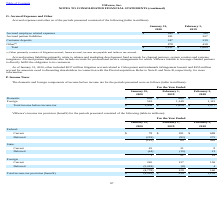From Vmware's financial document, Which years does the table provide information for the domestic and foreign components of income before income tax? The document contains multiple relevant values: 2020, 2019, 2018. From the document: "2020 2019 2020 2019 2020 2019 2018..." Also, What was the domestic income in 2020? According to the financial document, 895 (in millions). The relevant text states: "Domestic $ 895 $ 680 $ 462..." Also, What was the foreign income in 2018? According to the financial document, 1,115 (in millions). The relevant text states: "Foreign 543 1,149 1,115..." Also, can you calculate: What was the change in Foreign income between 2018 and 2019? Based on the calculation: 1,149-1,115, the result is 34 (in millions). This is based on the information: "Foreign 543 1,149 1,115 Foreign 543 1,149 1,115..." The key data points involved are: 1,115, 1,149. Also, How many years did Domestic income exceed $500 million? Counting the relevant items in the document: 2020, 2019, I find 2 instances. The key data points involved are: 2019, 2020. Also, can you calculate: What was the percentage change in the total income before income tax between 2019 and 2020? To answer this question, I need to perform calculations using the financial data. The calculation is: (1,438-1,829)/1,829, which equals -21.38 (percentage). This is based on the information: "Total income before income tax $ 1,438 $ 1,829 $ 1,577 Total income before income tax $ 1,438 $ 1,829 $ 1,577..." The key data points involved are: 1,438, 1,829. 